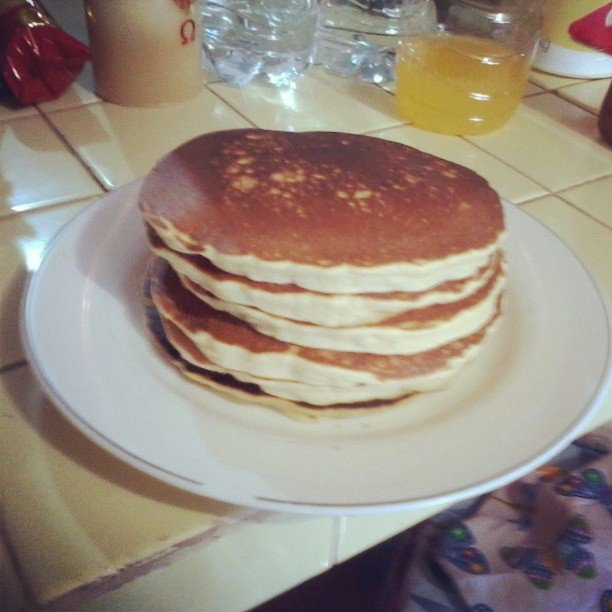Describe the objects in this image and their specific colors. I can see dining table in darkgray, brown, tan, maroon, and lightgray tones, bottle in black, tan, olive, and gray tones, cup in black, tan, gray, brown, and maroon tones, bottle in black, darkgray, gray, and lightblue tones, and bottle in black, darkgray, and gray tones in this image. 